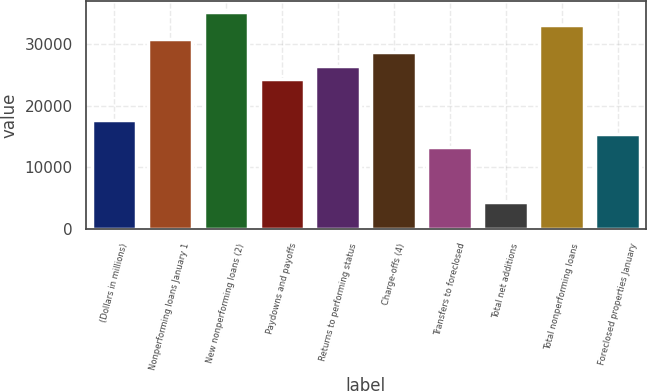Convert chart. <chart><loc_0><loc_0><loc_500><loc_500><bar_chart><fcel>(Dollars in millions)<fcel>Nonperforming loans January 1<fcel>New nonperforming loans (2)<fcel>Paydowns and payoffs<fcel>Returns to performing status<fcel>Charge-offs (4)<fcel>Transfers to foreclosed<fcel>Total net additions<fcel>Total nonperforming loans<fcel>Foreclosed properties January<nl><fcel>17683.1<fcel>30943<fcel>35362.9<fcel>24313<fcel>26523<fcel>28733<fcel>13263.1<fcel>4423.2<fcel>33152.9<fcel>15473.1<nl></chart> 